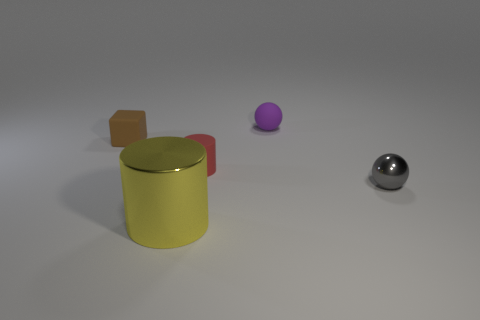Does the scene in the image seem to be arranged intentionally? Yes, the objects are placed in a way that suggests deliberate positioning, likely for the purpose of visualization or a rendering demonstration.  Could you tell me what material the objects might be made of based on their appearance? The small ball appears to be made of a polished metal, possibly steel, due to its reflective surface. The cylindrical container looks like it could be made of plastic or metal given its matte finish, and the lid seems like it could be a reflective metal as well. 